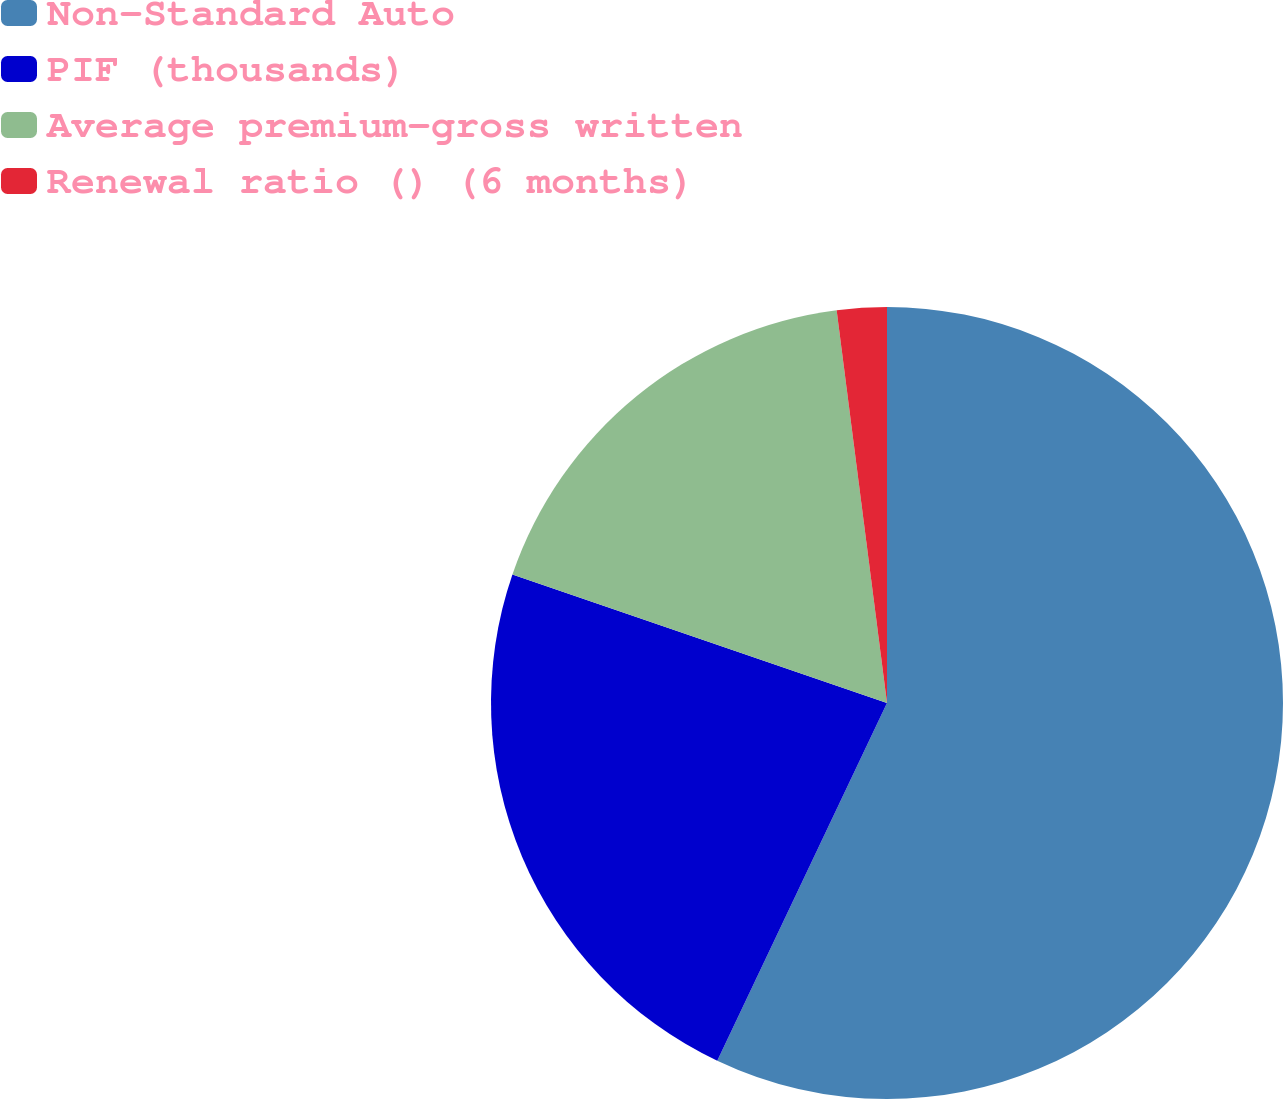Convert chart. <chart><loc_0><loc_0><loc_500><loc_500><pie_chart><fcel>Non-Standard Auto<fcel>PIF (thousands)<fcel>Average premium-gross written<fcel>Renewal ratio () (6 months)<nl><fcel>57.05%<fcel>23.21%<fcel>17.71%<fcel>2.03%<nl></chart> 